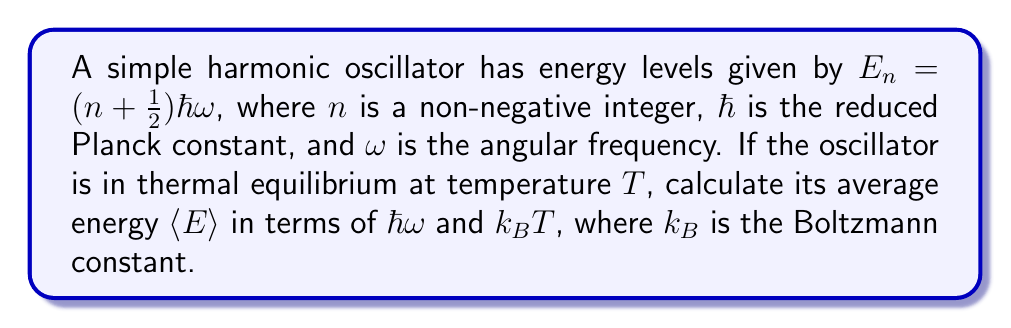Teach me how to tackle this problem. Let's approach this step-by-step:

1) In thermal equilibrium, the probability of the oscillator being in state $n$ is given by the Boltzmann distribution:

   $$P_n = \frac{e^{-E_n/k_BT}}{Z}$$

   where $Z$ is the partition function.

2) The partition function $Z$ is given by:

   $$Z = \sum_{n=0}^{\infty} e^{-E_n/k_BT} = \sum_{n=0}^{\infty} e^{-(n+1/2)\hbar\omega/k_BT}$$

3) This is a geometric series with first term $a = e^{-\hbar\omega/2k_BT}$ and common ratio $r = e^{-\hbar\omega/k_BT}$. The sum of this infinite series is:

   $$Z = \frac{a}{1-r} = \frac{e^{-\hbar\omega/2k_BT}}{1-e^{-\hbar\omega/k_BT}}$$

4) The average energy is given by:

   $$\langle E \rangle = \sum_{n=0}^{\infty} E_n P_n = \frac{1}{Z} \sum_{n=0}^{\infty} E_n e^{-E_n/k_BT}$$

5) Substituting $E_n = (n + \frac{1}{2})\hbar\omega$:

   $$\langle E \rangle = \frac{1}{Z} \sum_{n=0}^{\infty} (n + \frac{1}{2})\hbar\omega e^{-(n+1/2)\hbar\omega/k_BT}$$

6) This sum can be evaluated using the properties of geometric series and their derivatives. After some algebra, we get:

   $$\langle E \rangle = \frac{\hbar\omega}{2} + \frac{\hbar\omega}{e^{\hbar\omega/k_BT} - 1}$$

7) This can be rewritten as:

   $$\langle E \rangle = \frac{\hbar\omega}{2} \coth(\frac{\hbar\omega}{2k_BT})$$

This is the final expression for the average energy of a quantum harmonic oscillator in thermal equilibrium.
Answer: $\langle E \rangle = \frac{\hbar\omega}{2} \coth(\frac{\hbar\omega}{2k_BT})$ 